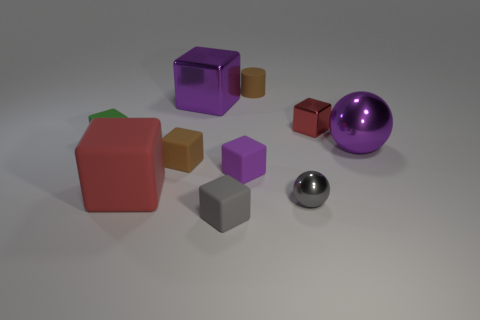Subtract all big blocks. How many blocks are left? 5 Subtract all brown cubes. How many cubes are left? 6 Subtract all green cubes. Subtract all red balls. How many cubes are left? 6 Subtract all cylinders. How many objects are left? 9 Add 3 red metallic spheres. How many red metallic spheres exist? 3 Subtract 0 red spheres. How many objects are left? 10 Subtract all rubber things. Subtract all tiny red cubes. How many objects are left? 3 Add 2 small metal things. How many small metal things are left? 4 